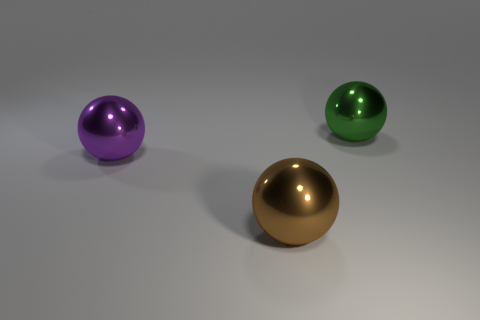There is a green ball that is the same size as the purple ball; what material is it?
Your answer should be very brief. Metal. Is there a green metal object of the same size as the green ball?
Give a very brief answer. No. There is a ball behind the purple object; what material is it?
Ensure brevity in your answer.  Metal. Is the green sphere that is behind the purple metallic thing made of the same material as the large brown thing?
Give a very brief answer. Yes. There is a purple metallic object that is the same size as the brown ball; what shape is it?
Offer a terse response. Sphere. Are there fewer things right of the brown object than objects that are left of the green metal sphere?
Keep it short and to the point. Yes. There is a large green metal thing; are there any big green objects in front of it?
Your answer should be compact. No. There is a large sphere that is left of the large metal object in front of the big purple metallic ball; is there a green metallic sphere in front of it?
Make the answer very short. No. There is a thing that is on the right side of the brown object; is its shape the same as the purple shiny object?
Your answer should be compact. Yes. What number of large things are made of the same material as the large brown ball?
Your answer should be compact. 2. 